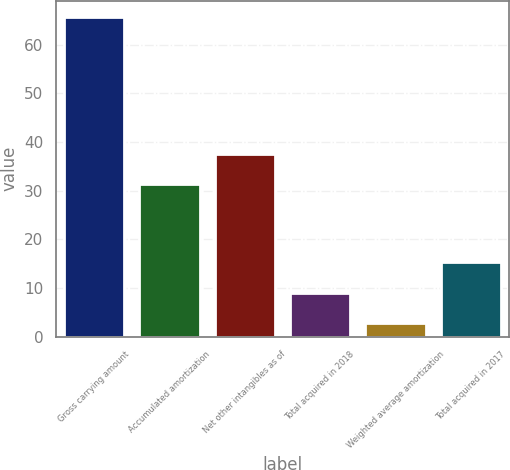<chart> <loc_0><loc_0><loc_500><loc_500><bar_chart><fcel>Gross carrying amount<fcel>Accumulated amortization<fcel>Net other intangibles as of<fcel>Total acquired in 2018<fcel>Weighted average amortization<fcel>Total acquired in 2017<nl><fcel>65.8<fcel>31.3<fcel>37.61<fcel>9.01<fcel>2.7<fcel>15.32<nl></chart> 